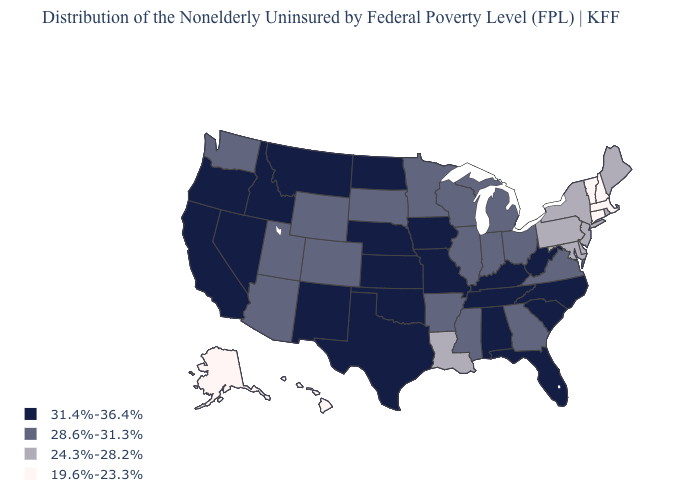What is the highest value in states that border Kentucky?
Short answer required. 31.4%-36.4%. What is the value of Montana?
Answer briefly. 31.4%-36.4%. Name the states that have a value in the range 19.6%-23.3%?
Write a very short answer. Alaska, Connecticut, Hawaii, Massachusetts, New Hampshire, Vermont. Which states have the lowest value in the West?
Keep it brief. Alaska, Hawaii. What is the highest value in the USA?
Answer briefly. 31.4%-36.4%. Which states have the lowest value in the USA?
Write a very short answer. Alaska, Connecticut, Hawaii, Massachusetts, New Hampshire, Vermont. Does Rhode Island have the highest value in the Northeast?
Answer briefly. Yes. Does Utah have a higher value than Pennsylvania?
Write a very short answer. Yes. Among the states that border Montana , does Idaho have the highest value?
Quick response, please. Yes. Name the states that have a value in the range 24.3%-28.2%?
Keep it brief. Delaware, Louisiana, Maine, Maryland, New Jersey, New York, Pennsylvania, Rhode Island. Name the states that have a value in the range 28.6%-31.3%?
Keep it brief. Arizona, Arkansas, Colorado, Georgia, Illinois, Indiana, Michigan, Minnesota, Mississippi, Ohio, South Dakota, Utah, Virginia, Washington, Wisconsin, Wyoming. What is the value of Ohio?
Keep it brief. 28.6%-31.3%. What is the value of Maine?
Write a very short answer. 24.3%-28.2%. Is the legend a continuous bar?
Quick response, please. No. Does West Virginia have the highest value in the USA?
Short answer required. Yes. 